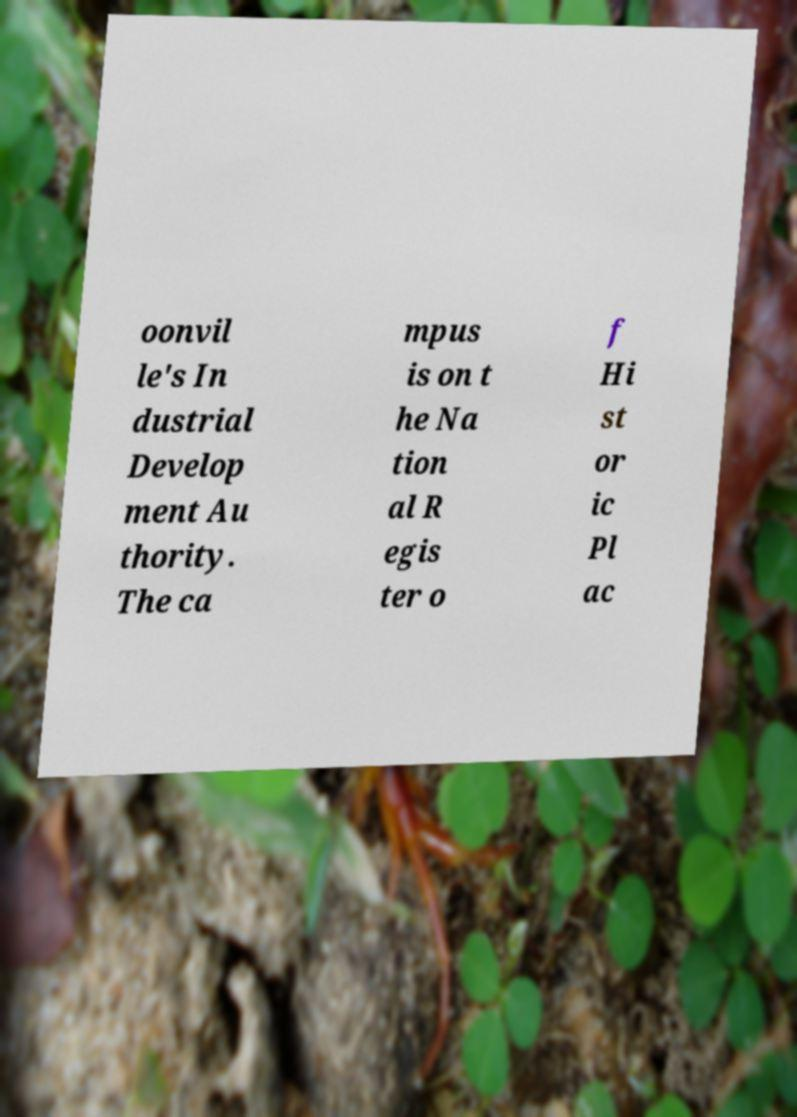Please identify and transcribe the text found in this image. oonvil le's In dustrial Develop ment Au thority. The ca mpus is on t he Na tion al R egis ter o f Hi st or ic Pl ac 